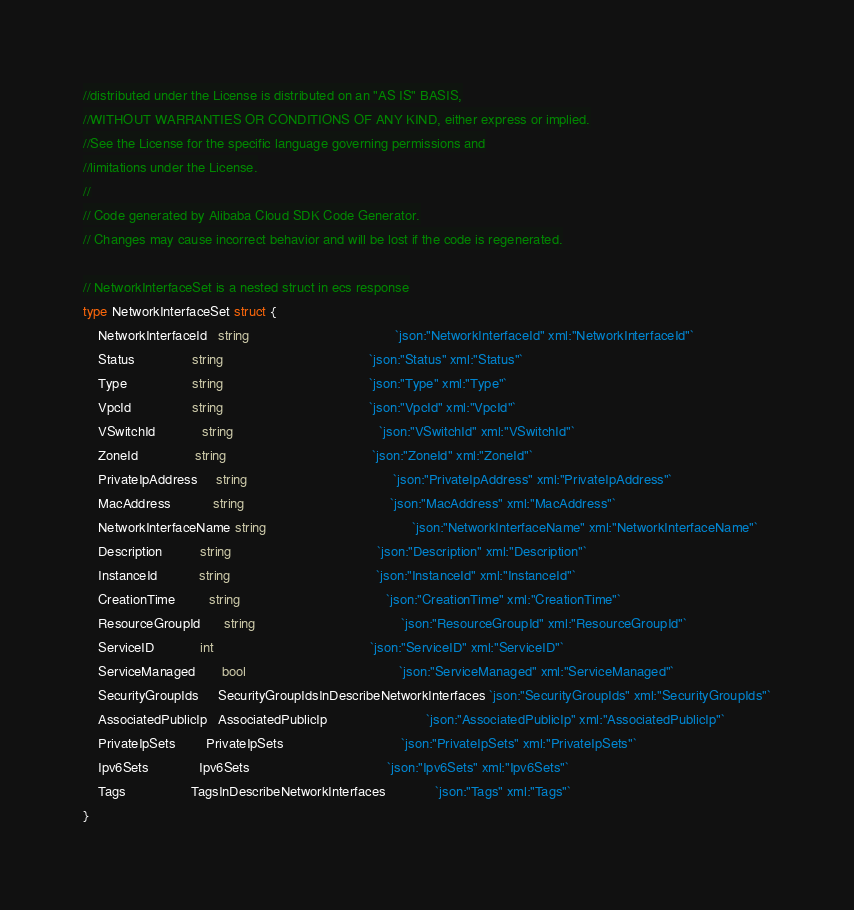<code> <loc_0><loc_0><loc_500><loc_500><_Go_>//distributed under the License is distributed on an "AS IS" BASIS,
//WITHOUT WARRANTIES OR CONDITIONS OF ANY KIND, either express or implied.
//See the License for the specific language governing permissions and
//limitations under the License.
//
// Code generated by Alibaba Cloud SDK Code Generator.
// Changes may cause incorrect behavior and will be lost if the code is regenerated.

// NetworkInterfaceSet is a nested struct in ecs response
type NetworkInterfaceSet struct {
	NetworkInterfaceId   string                                      `json:"NetworkInterfaceId" xml:"NetworkInterfaceId"`
	Status               string                                      `json:"Status" xml:"Status"`
	Type                 string                                      `json:"Type" xml:"Type"`
	VpcId                string                                      `json:"VpcId" xml:"VpcId"`
	VSwitchId            string                                      `json:"VSwitchId" xml:"VSwitchId"`
	ZoneId               string                                      `json:"ZoneId" xml:"ZoneId"`
	PrivateIpAddress     string                                      `json:"PrivateIpAddress" xml:"PrivateIpAddress"`
	MacAddress           string                                      `json:"MacAddress" xml:"MacAddress"`
	NetworkInterfaceName string                                      `json:"NetworkInterfaceName" xml:"NetworkInterfaceName"`
	Description          string                                      `json:"Description" xml:"Description"`
	InstanceId           string                                      `json:"InstanceId" xml:"InstanceId"`
	CreationTime         string                                      `json:"CreationTime" xml:"CreationTime"`
	ResourceGroupId      string                                      `json:"ResourceGroupId" xml:"ResourceGroupId"`
	ServiceID            int                                         `json:"ServiceID" xml:"ServiceID"`
	ServiceManaged       bool                                        `json:"ServiceManaged" xml:"ServiceManaged"`
	SecurityGroupIds     SecurityGroupIdsInDescribeNetworkInterfaces `json:"SecurityGroupIds" xml:"SecurityGroupIds"`
	AssociatedPublicIp   AssociatedPublicIp                          `json:"AssociatedPublicIp" xml:"AssociatedPublicIp"`
	PrivateIpSets        PrivateIpSets                               `json:"PrivateIpSets" xml:"PrivateIpSets"`
	Ipv6Sets             Ipv6Sets                                    `json:"Ipv6Sets" xml:"Ipv6Sets"`
	Tags                 TagsInDescribeNetworkInterfaces             `json:"Tags" xml:"Tags"`
}
</code> 